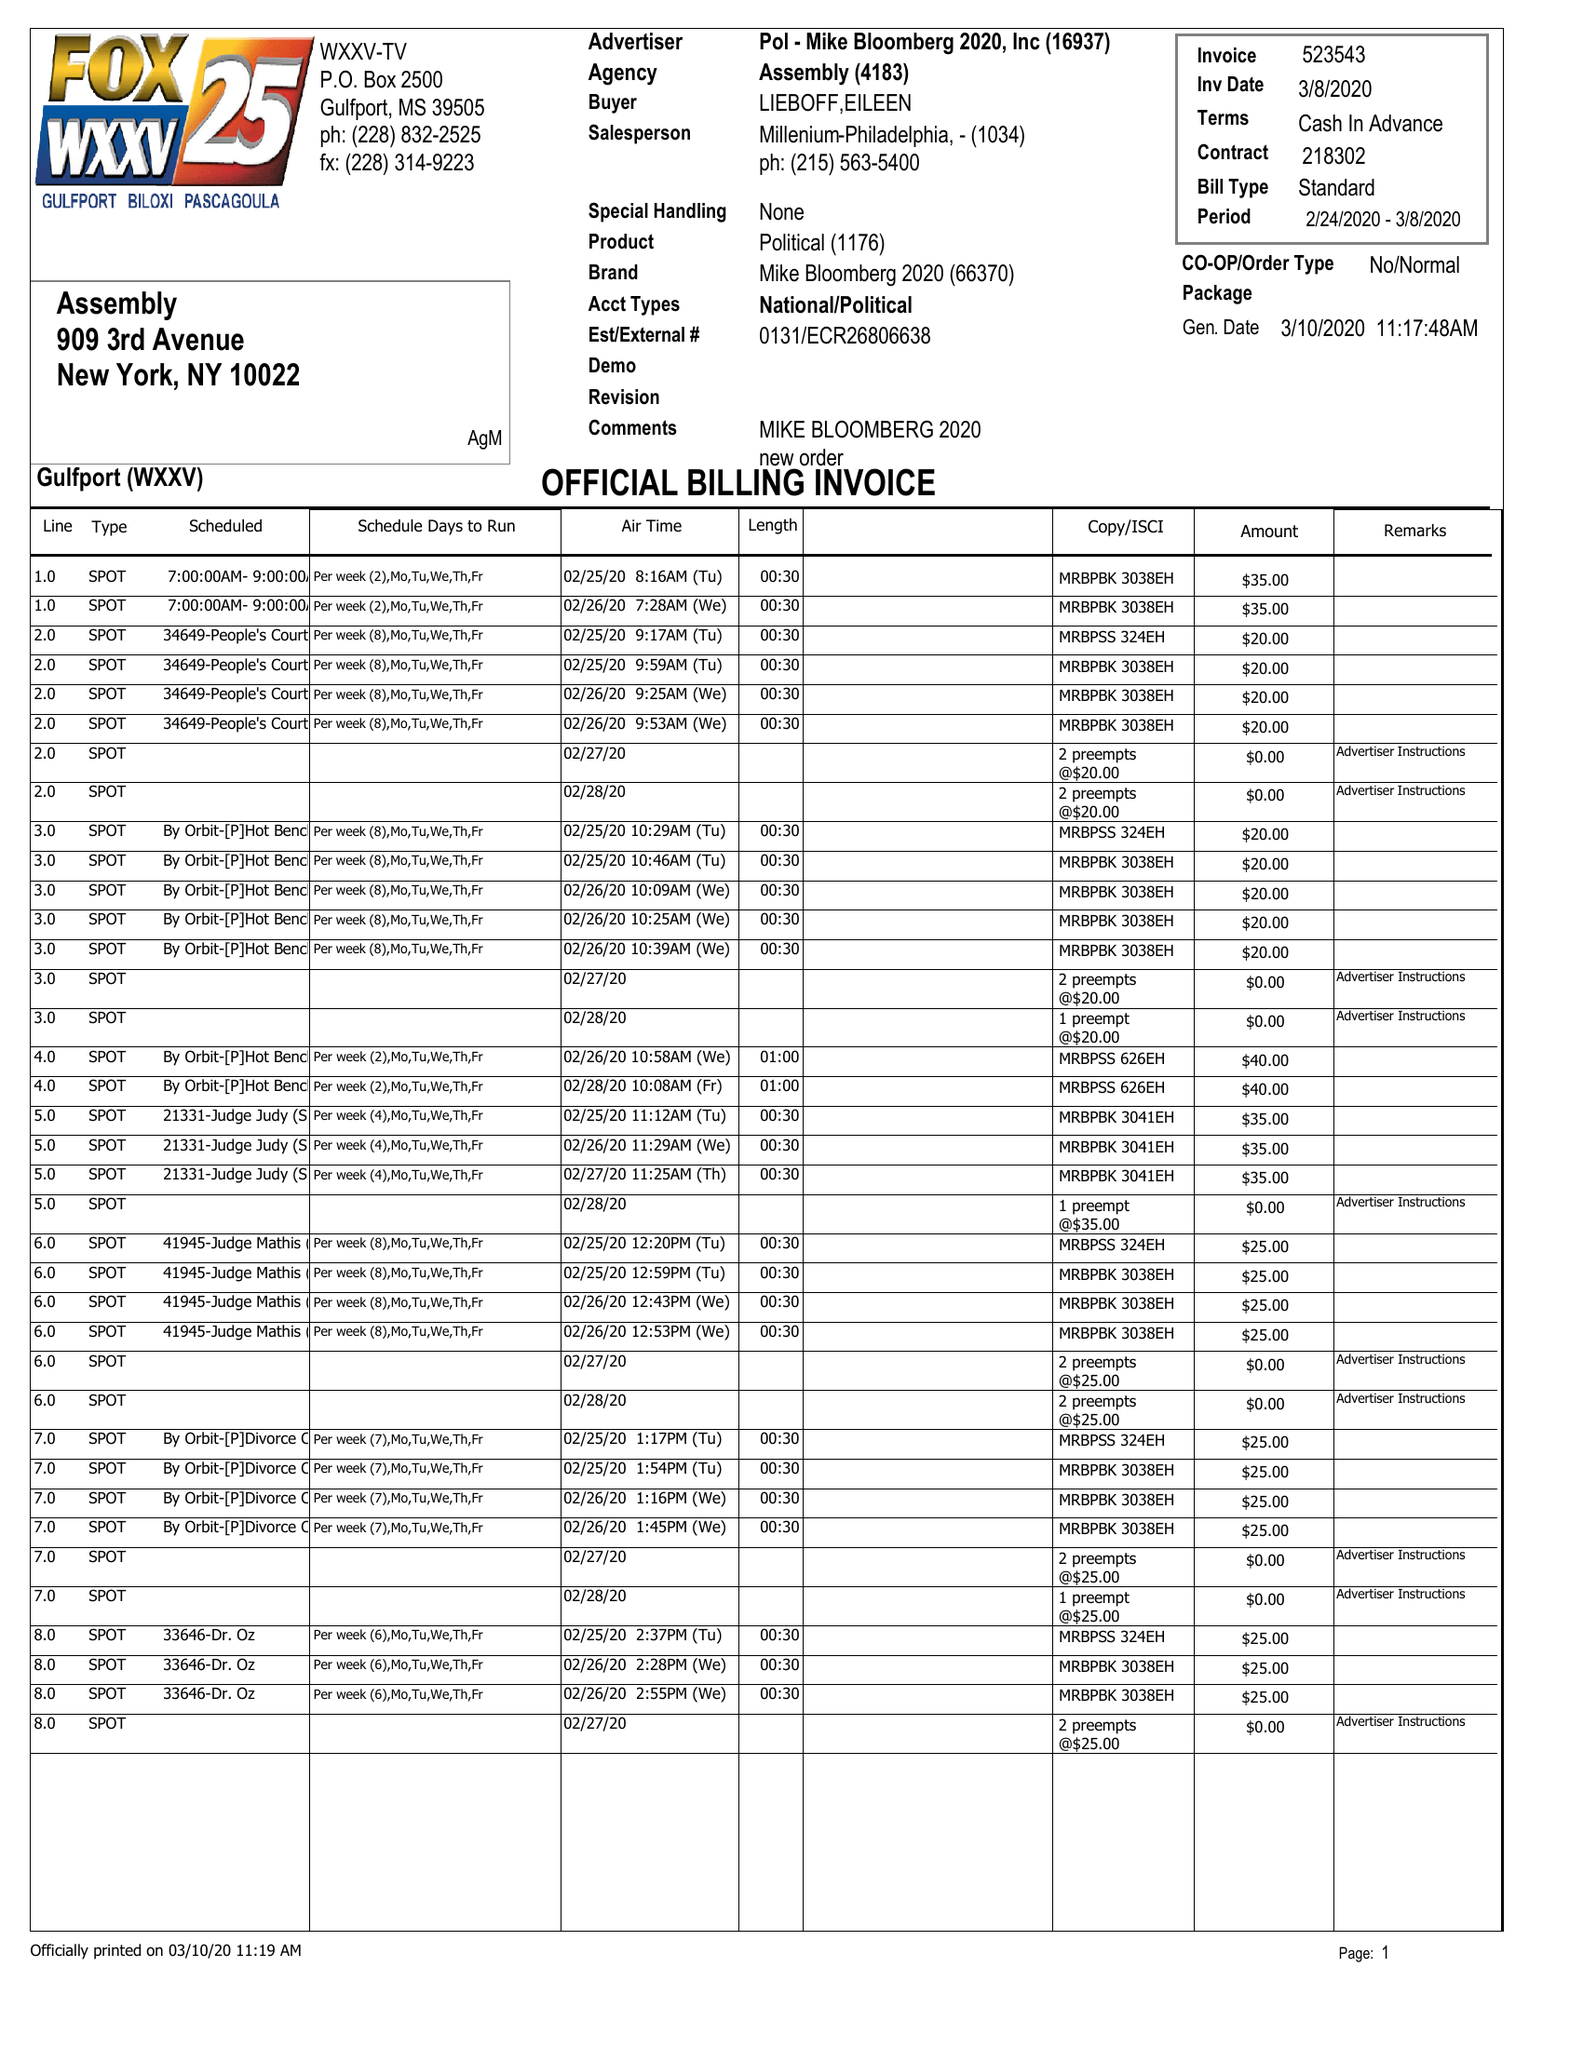What is the value for the flight_from?
Answer the question using a single word or phrase. 02/24/20 